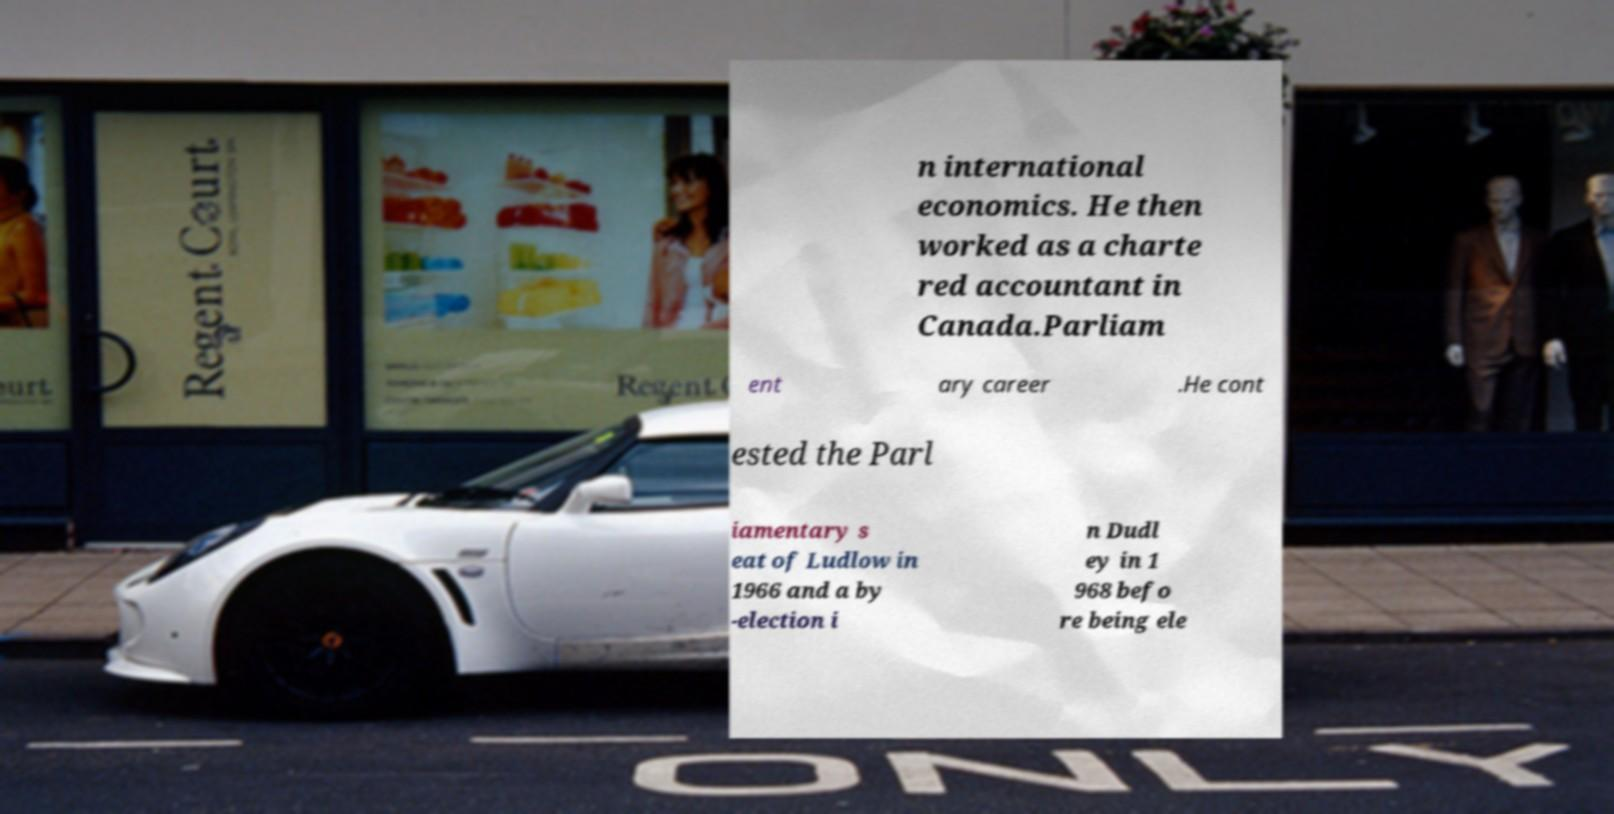I need the written content from this picture converted into text. Can you do that? n international economics. He then worked as a charte red accountant in Canada.Parliam ent ary career .He cont ested the Parl iamentary s eat of Ludlow in 1966 and a by -election i n Dudl ey in 1 968 befo re being ele 